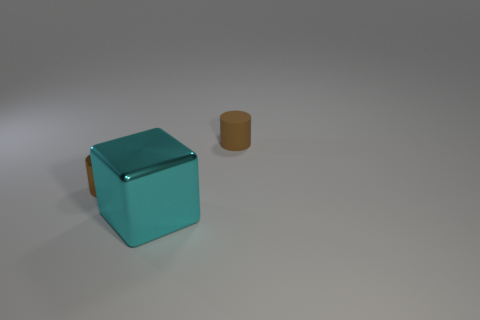What is the color of the cylinder that is the same size as the brown metal object?
Offer a very short reply. Brown. How many yellow objects are big things or matte cylinders?
Offer a terse response. 0. Is the number of yellow rubber cubes greater than the number of small brown cylinders?
Offer a terse response. No. Is the size of the brown thing that is left of the big block the same as the cylinder right of the large object?
Offer a terse response. Yes. What is the color of the tiny cylinder left of the small brown cylinder behind the metallic thing left of the cyan metal cube?
Provide a short and direct response. Brown. Are there any other objects that have the same shape as the cyan metal thing?
Give a very brief answer. No. Are there more tiny brown objects that are right of the large object than small purple rubber blocks?
Provide a succinct answer. Yes. What number of metallic objects are either small purple cylinders or large blocks?
Provide a short and direct response. 1. There is a thing that is both left of the matte object and behind the large object; what is its size?
Your answer should be compact. Small. Are there any brown cylinders behind the cylinder to the left of the big cyan block?
Offer a very short reply. Yes. 